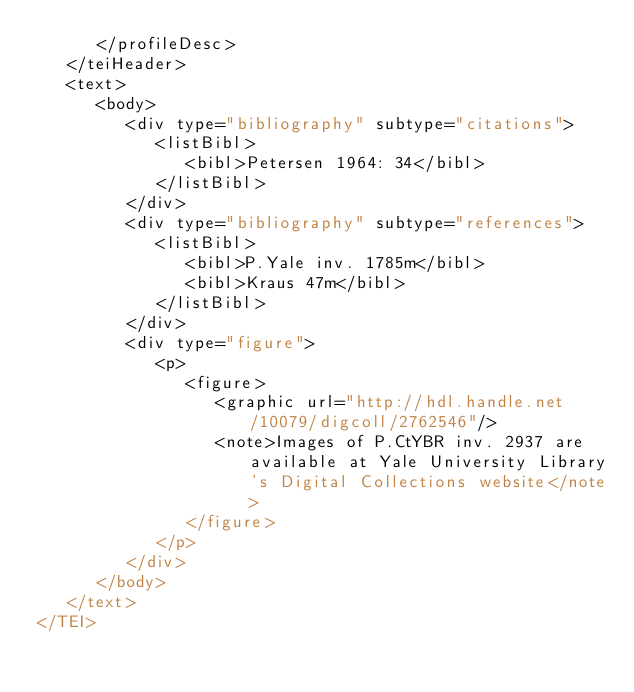<code> <loc_0><loc_0><loc_500><loc_500><_XML_>      </profileDesc>
   </teiHeader>
   <text>
      <body>
         <div type="bibliography" subtype="citations">
            <listBibl>
               <bibl>Petersen 1964: 34</bibl>
            </listBibl>
         </div>
         <div type="bibliography" subtype="references">
            <listBibl>
               <bibl>P.Yale inv. 1785m</bibl>
               <bibl>Kraus 47m</bibl>
            </listBibl>
         </div>
         <div type="figure">
            <p>
               <figure>
                  <graphic url="http://hdl.handle.net/10079/digcoll/2762546"/>
                  <note>Images of P.CtYBR inv. 2937 are available at Yale University Library's Digital Collections website</note>
               </figure>
            </p>
         </div>
      </body>
   </text>
</TEI>
</code> 